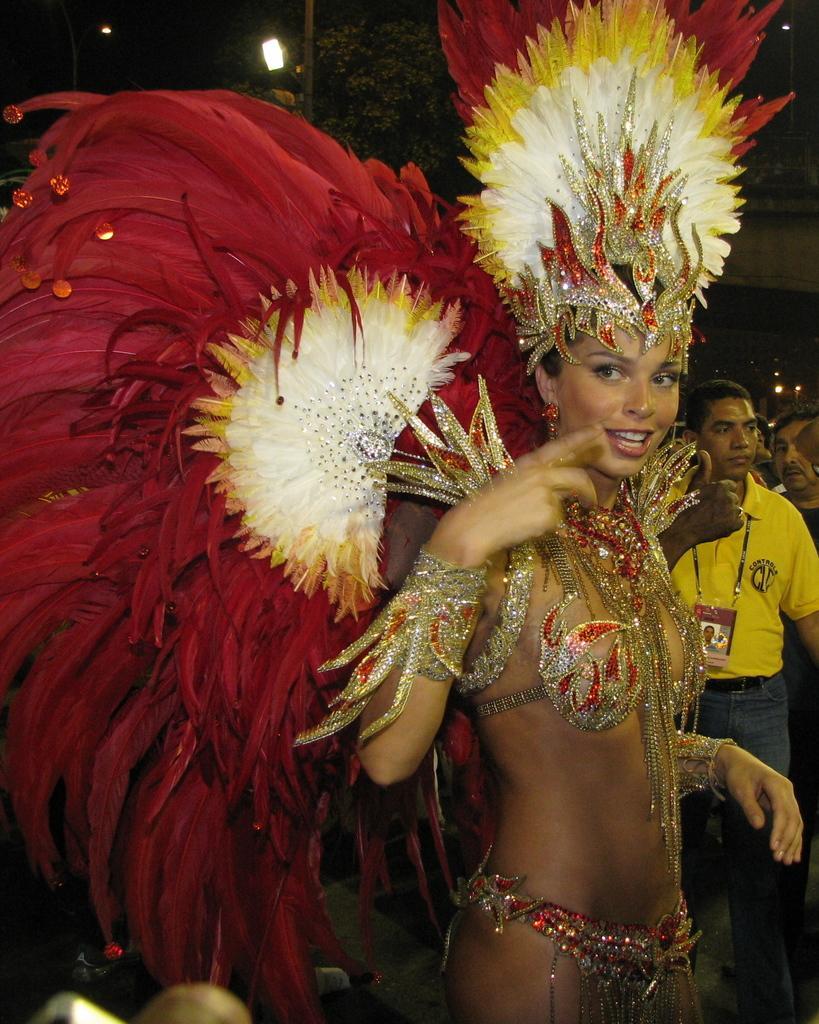Can you describe this image briefly? In the picture we can see a woman standing with with a costume of red colored feathers and beside her we can see a man standing with yellow T-shirt and ID card and in the background we can see some lights in the dark. 